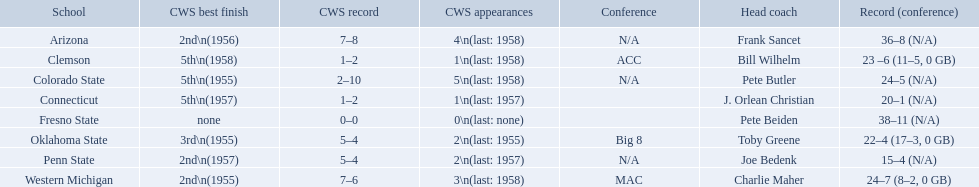What are all the schools? Arizona, Clemson, Colorado State, Connecticut, Fresno State, Oklahoma State, Penn State, Western Michigan. Which are clemson and western michigan? Clemson, Western Michigan. Of these, which has more cws appearances? Western Michigan. What are all the school names? Arizona, Clemson, Colorado State, Connecticut, Fresno State, Oklahoma State, Penn State, Western Michigan. What is the record for each? 36–8 (N/A), 23 –6 (11–5, 0 GB), 24–5 (N/A), 20–1 (N/A), 38–11 (N/A), 22–4 (17–3, 0 GB), 15–4 (N/A), 24–7 (8–2, 0 GB). Which school had the fewest number of wins? Penn State. Which teams played in the 1959 ncaa university division baseball tournament? Arizona, Clemson, Colorado State, Connecticut, Fresno State, Oklahoma State, Penn State, Western Michigan. Which was the only one to win less than 20 games? Penn State. 